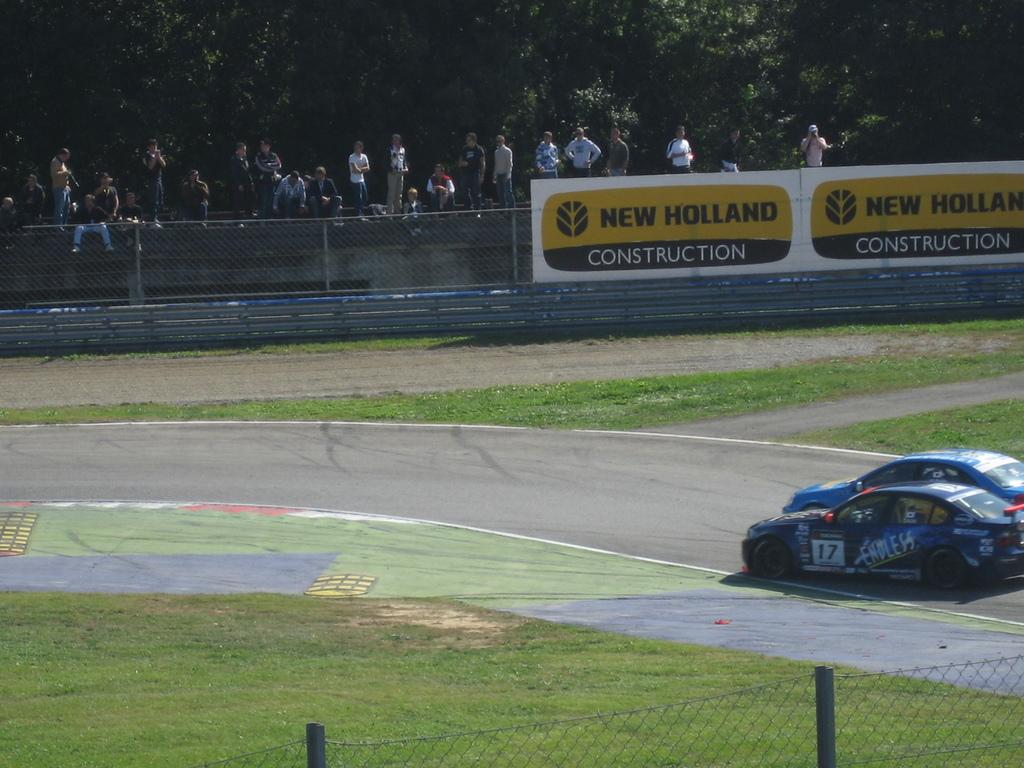Who or what can be seen in the image? There are people in the image. What else is visible on the road in the image? There are cars on the road in the image. What type of vegetation is present in the image? There are trees and grass in the image. What kind of signs or messages are displayed in the image? There are boards with text in the image. What type of barrier is present in the image? There is fencing in the image. What structures can be seen supporting wires or other objects in the image? There are poles in the image. Can you tell me how many snails are crawling on the poles in the image? There are no snails present in the image; the poles are supporting wires or other objects. What type of exercise do the people in the image engage in? The provided facts do not mention any specific exercise or activity that the people in the image are engaged in. --- Facts: 1. There is a person holding a book in the image. 2. The person is sitting on a chair. 3. There is a table in the image. 4. The table has a lamp on it. 5. There is a window in the image. 6. The window has curtains. Absurd Topics: dance, parrot, sand Conversation: What is the person in the image holding? The person in the image is holding a book. What is the person's seating arrangement in the image? The person is sitting on a chair. What piece of furniture is present in the image besides the chair? There is a table in the image. What object is on the table in the image? The table has a lamp on it. What can be seen in the background of the image? There is a window in the image, and it has curtains. Reasoning: Let's think step by step in order to produce the conversation. We start by identifying the main subject in the image, which is the person holding a book. Then, we expand the conversation to include other items that are also visible, such as the chair, table, lamp, window, and curtains. Each question is designed to elicit a specific detail about the image that is known from the provided facts. Absurd Question/Answer: What type of dance is the person performing in the image? There is no indication of any dance in the image; the person is sitting and holding a book. Can you tell me how many parrots are sitting on the chair in the image? There are no parrots present in the image; the person is sitting on the chair. 